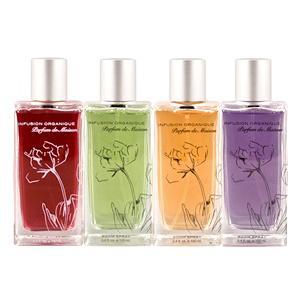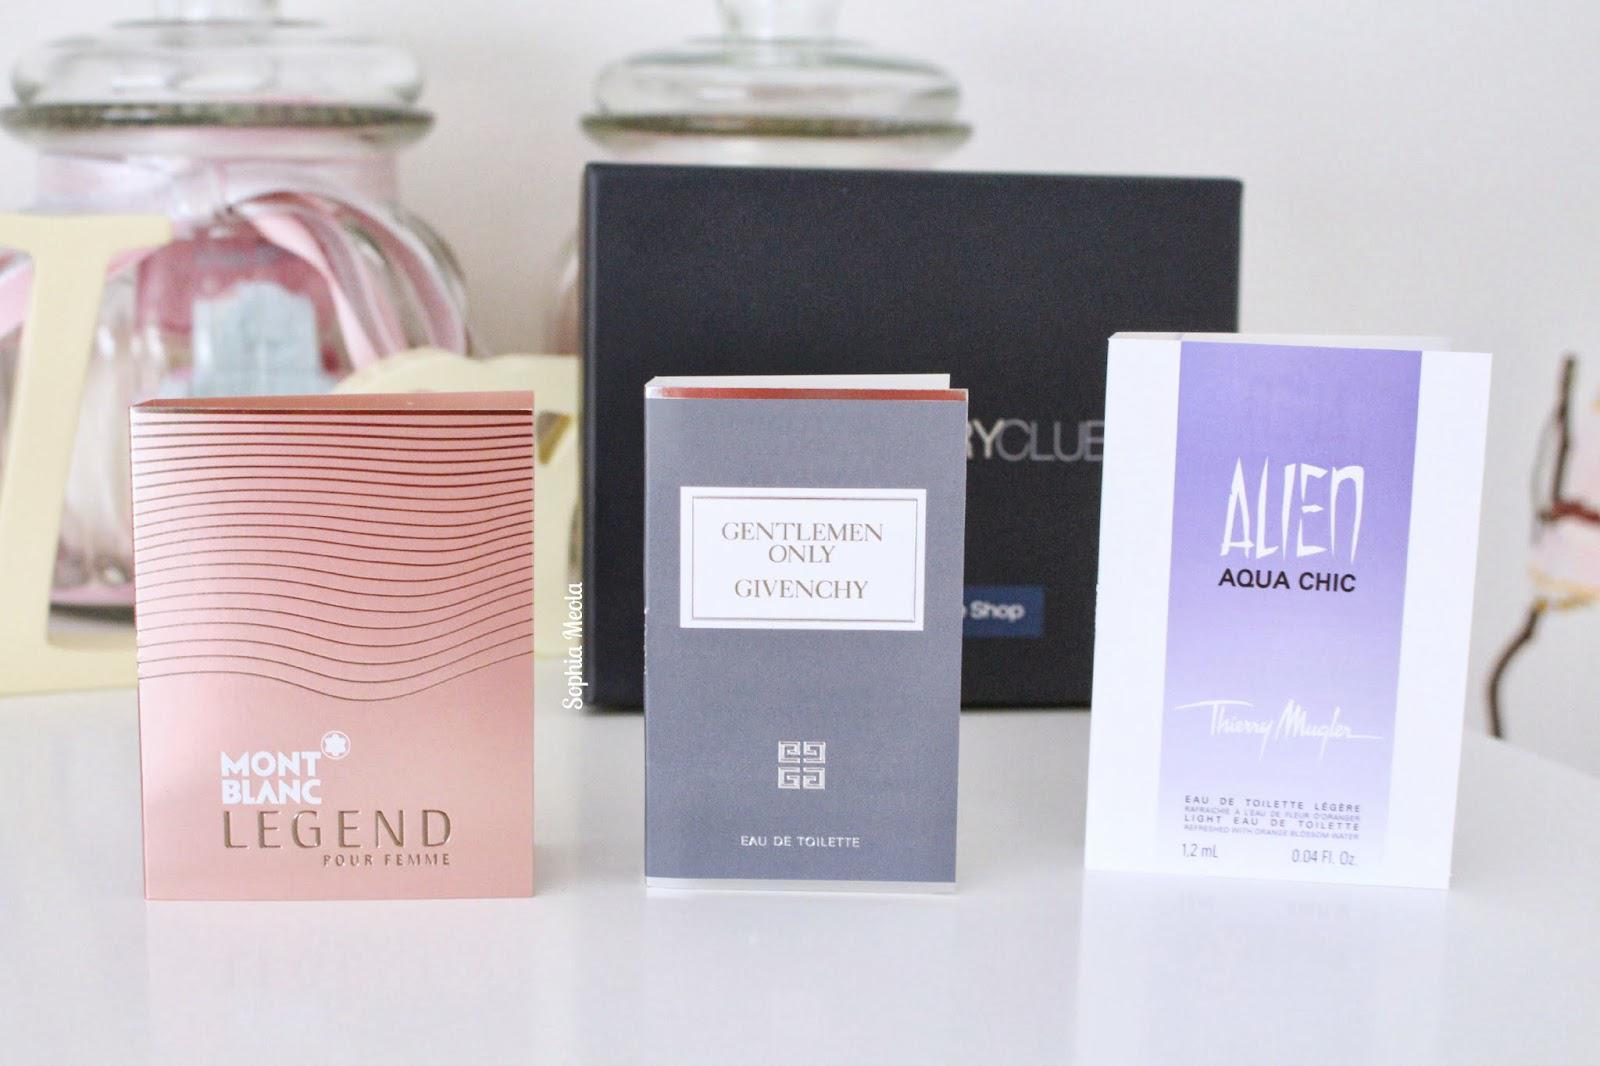The first image is the image on the left, the second image is the image on the right. For the images displayed, is the sentence "One box contains multiple items." factually correct? Answer yes or no. No. 